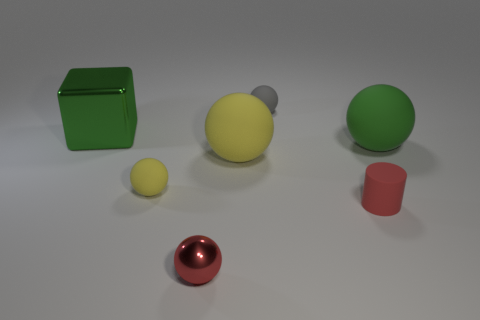Subtract all tiny gray spheres. How many spheres are left? 4 Subtract all gray spheres. How many spheres are left? 4 Subtract 2 balls. How many balls are left? 3 Subtract all purple balls. Subtract all yellow cylinders. How many balls are left? 5 Add 1 small green shiny blocks. How many objects exist? 8 Subtract all spheres. How many objects are left? 2 Add 5 tiny shiny spheres. How many tiny shiny spheres are left? 6 Add 6 tiny cyan things. How many tiny cyan things exist? 6 Subtract 0 yellow cylinders. How many objects are left? 7 Subtract all tiny green things. Subtract all gray matte things. How many objects are left? 6 